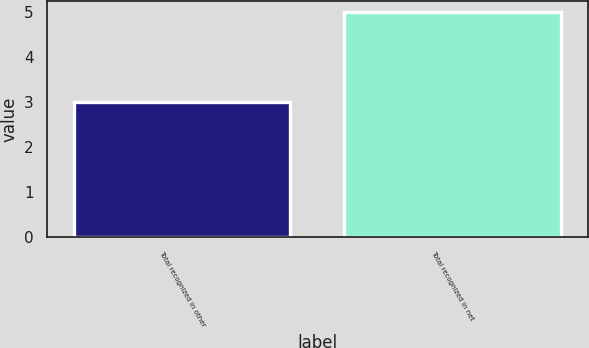Convert chart to OTSL. <chart><loc_0><loc_0><loc_500><loc_500><bar_chart><fcel>Total recognized in other<fcel>Total recognized in net<nl><fcel>3<fcel>5<nl></chart> 